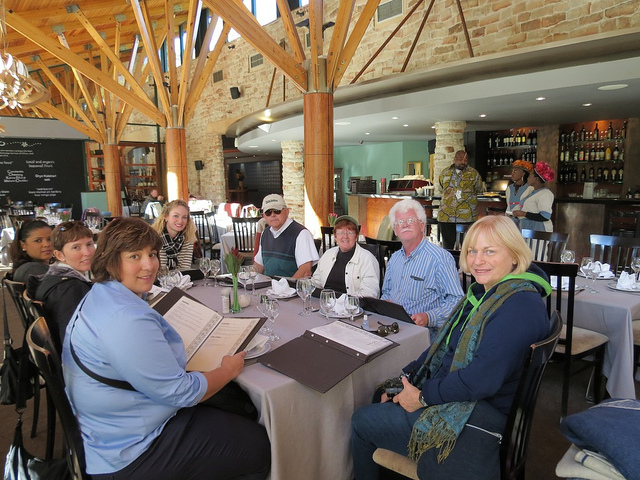What kind of establishment is shown in the image? The image depicts an interior that appears to be a rustic-style restaurant or dining venue, characterized by a cozy ambiance and a well-organized table arrangement. 